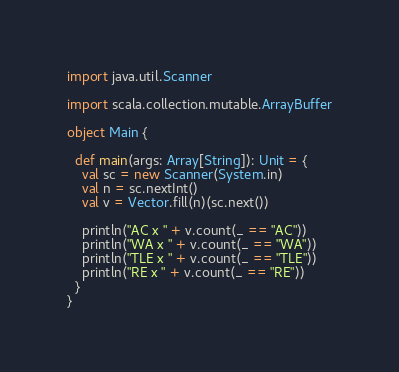Convert code to text. <code><loc_0><loc_0><loc_500><loc_500><_Scala_>import java.util.Scanner

import scala.collection.mutable.ArrayBuffer

object Main {

  def main(args: Array[String]): Unit = {
    val sc = new Scanner(System.in)
    val n = sc.nextInt()
    val v = Vector.fill(n)(sc.next())

    println("AC x " + v.count(_ == "AC"))
    println("WA x " + v.count(_ == "WA"))
    println("TLE x " + v.count(_ == "TLE"))
    println("RE x " + v.count(_ == "RE"))
  }
}
</code> 